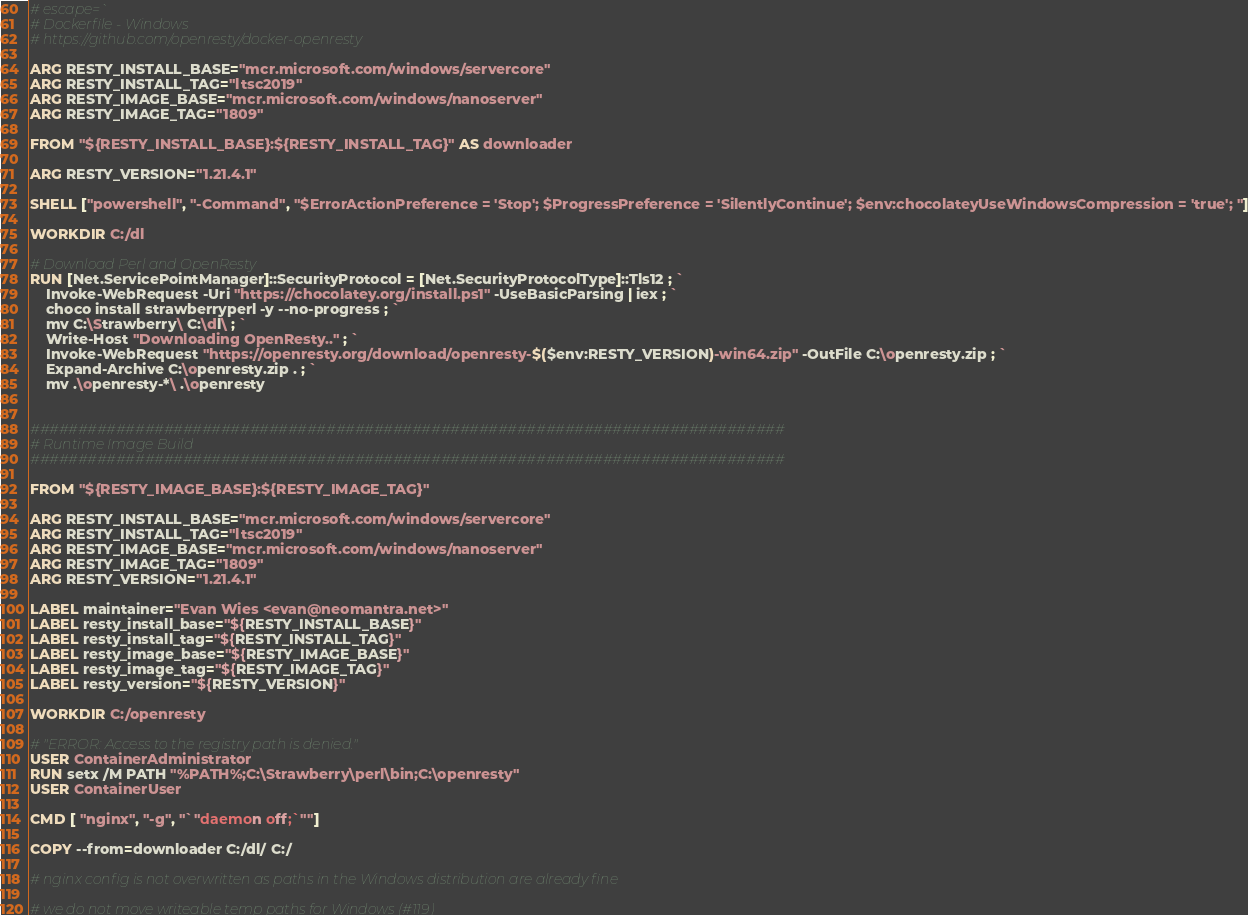<code> <loc_0><loc_0><loc_500><loc_500><_Dockerfile_># escape=`
# Dockerfile - Windows
# https://github.com/openresty/docker-openresty

ARG RESTY_INSTALL_BASE="mcr.microsoft.com/windows/servercore"
ARG RESTY_INSTALL_TAG="ltsc2019"
ARG RESTY_IMAGE_BASE="mcr.microsoft.com/windows/nanoserver"
ARG RESTY_IMAGE_TAG="1809"

FROM "${RESTY_INSTALL_BASE}:${RESTY_INSTALL_TAG}" AS downloader

ARG RESTY_VERSION="1.21.4.1"

SHELL ["powershell", "-Command", "$ErrorActionPreference = 'Stop'; $ProgressPreference = 'SilentlyContinue'; $env:chocolateyUseWindowsCompression = 'true'; "]

WORKDIR C:/dl

# Download Perl and OpenResty
RUN [Net.ServicePointManager]::SecurityProtocol = [Net.SecurityProtocolType]::Tls12 ; `
    Invoke-WebRequest -Uri "https://chocolatey.org/install.ps1" -UseBasicParsing | iex ; `
    choco install strawberryperl -y --no-progress ; `
    mv C:\Strawberry\ C:\dl\ ; `
    Write-Host "Downloading OpenResty.." ; `
    Invoke-WebRequest "https://openresty.org/download/openresty-$($env:RESTY_VERSION)-win64.zip" -OutFile C:\openresty.zip ; `
    Expand-Archive C:\openresty.zip . ; `
    mv .\openresty-*\ .\openresty


###############################################################################
# Runtime Image Build
###############################################################################

FROM "${RESTY_IMAGE_BASE}:${RESTY_IMAGE_TAG}"

ARG RESTY_INSTALL_BASE="mcr.microsoft.com/windows/servercore"
ARG RESTY_INSTALL_TAG="ltsc2019"
ARG RESTY_IMAGE_BASE="mcr.microsoft.com/windows/nanoserver"
ARG RESTY_IMAGE_TAG="1809"
ARG RESTY_VERSION="1.21.4.1"

LABEL maintainer="Evan Wies <evan@neomantra.net>"
LABEL resty_install_base="${RESTY_INSTALL_BASE}"
LABEL resty_install_tag="${RESTY_INSTALL_TAG}"
LABEL resty_image_base="${RESTY_IMAGE_BASE}"
LABEL resty_image_tag="${RESTY_IMAGE_TAG}"
LABEL resty_version="${RESTY_VERSION}"

WORKDIR C:/openresty

# "ERROR: Access to the registry path is denied."
USER ContainerAdministrator
RUN setx /M PATH "%PATH%;C:\Strawberry\perl\bin;C:\openresty"
USER ContainerUser

CMD [ "nginx", "-g", "`"daemon off;`""]

COPY --from=downloader C:/dl/ C:/

# nginx config is not overwritten as paths in the Windows distribution are already fine

# we do not move writeable temp paths for Windows (#119)
</code> 